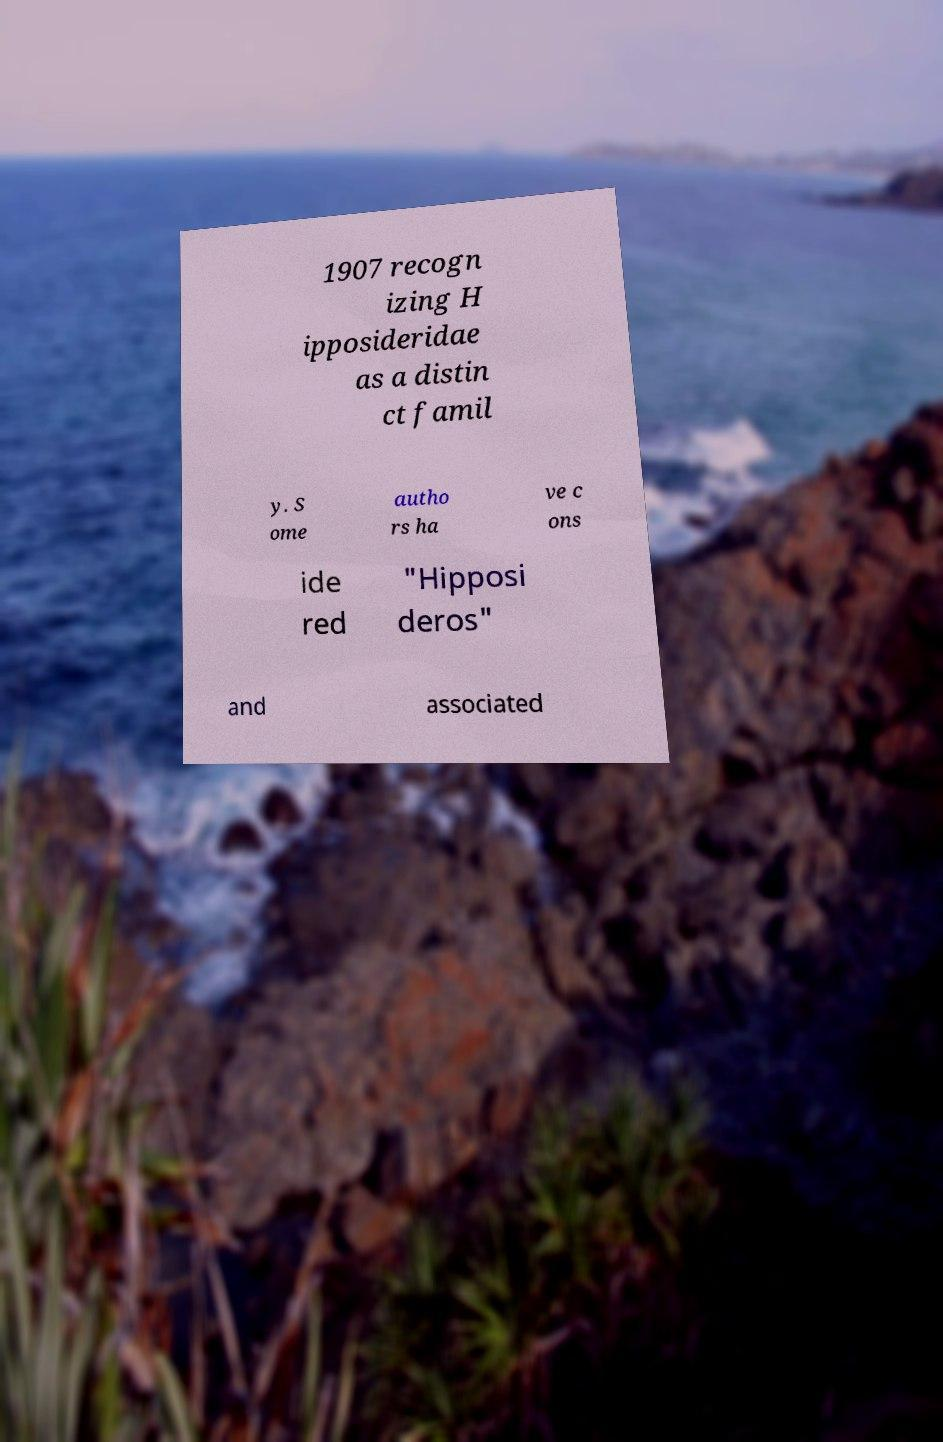I need the written content from this picture converted into text. Can you do that? 1907 recogn izing H ipposideridae as a distin ct famil y. S ome autho rs ha ve c ons ide red "Hipposi deros" and associated 